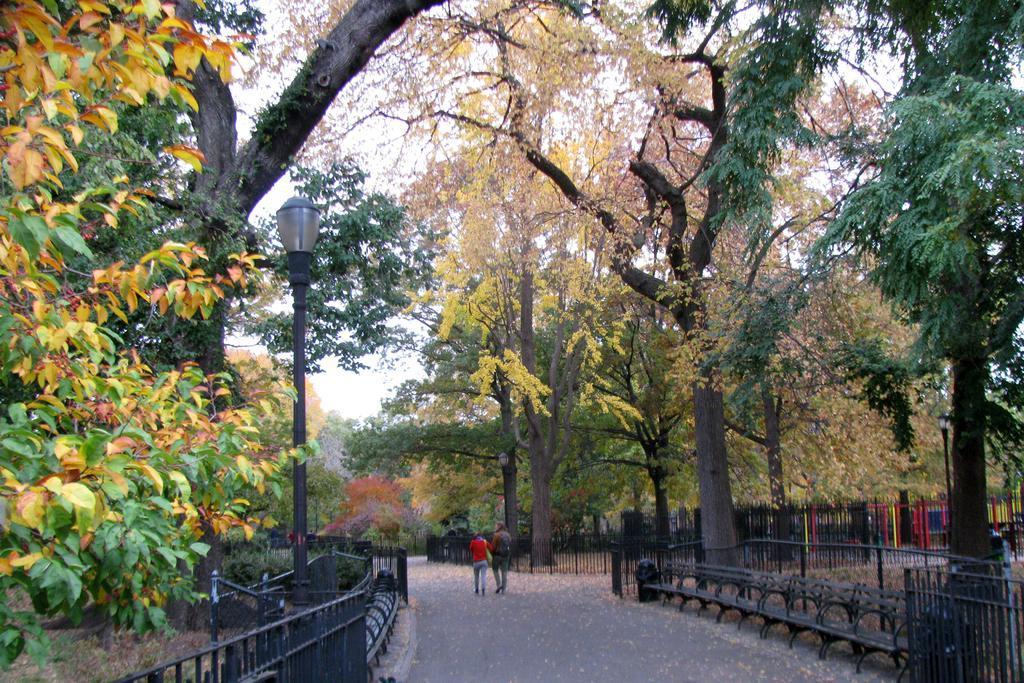Can you describe this image briefly? In this image two persons are walking on the road. Left side there is a street light. Behind the fence there are few plants and trees. Right side there is a bench. Behind there is fence. Background there are few trees. 